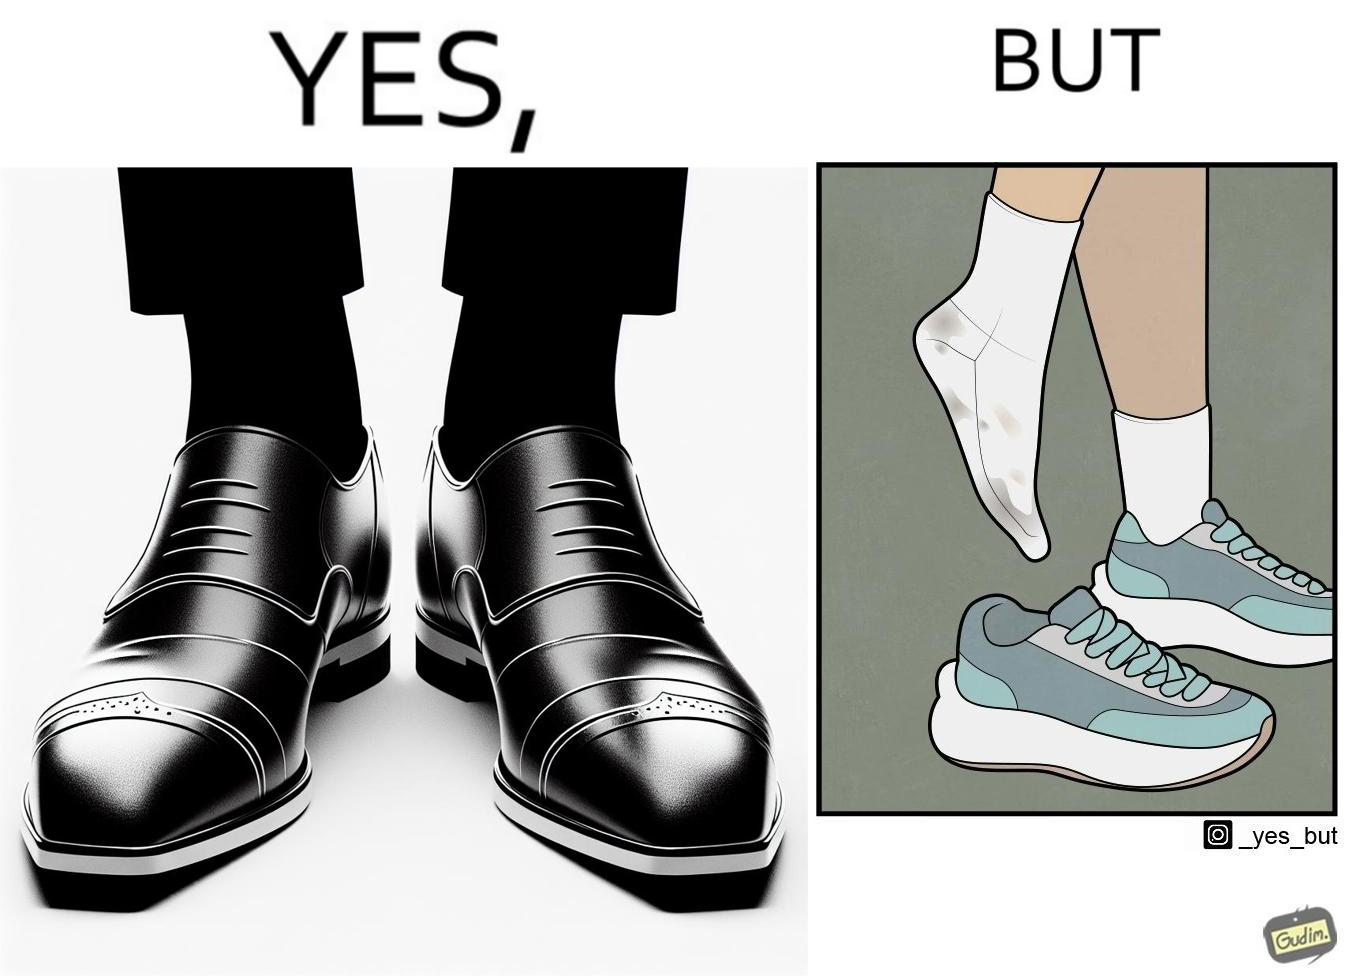Why is this image considered satirical? The person's shocks is very dirty although the shoes are very clean. Thus there is an irony that not all things are same as they appear. 